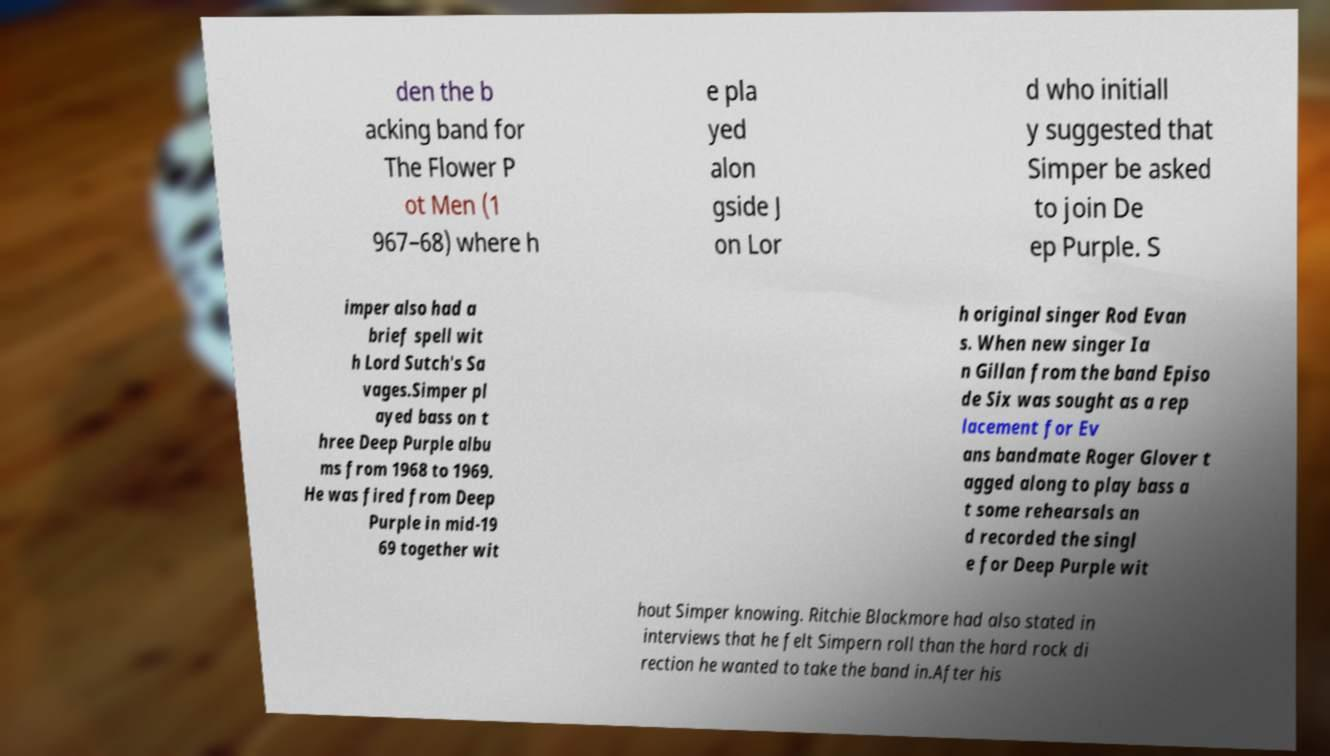Please identify and transcribe the text found in this image. den the b acking band for The Flower P ot Men (1 967–68) where h e pla yed alon gside J on Lor d who initiall y suggested that Simper be asked to join De ep Purple. S imper also had a brief spell wit h Lord Sutch's Sa vages.Simper pl ayed bass on t hree Deep Purple albu ms from 1968 to 1969. He was fired from Deep Purple in mid-19 69 together wit h original singer Rod Evan s. When new singer Ia n Gillan from the band Episo de Six was sought as a rep lacement for Ev ans bandmate Roger Glover t agged along to play bass a t some rehearsals an d recorded the singl e for Deep Purple wit hout Simper knowing. Ritchie Blackmore had also stated in interviews that he felt Simpern roll than the hard rock di rection he wanted to take the band in.After his 